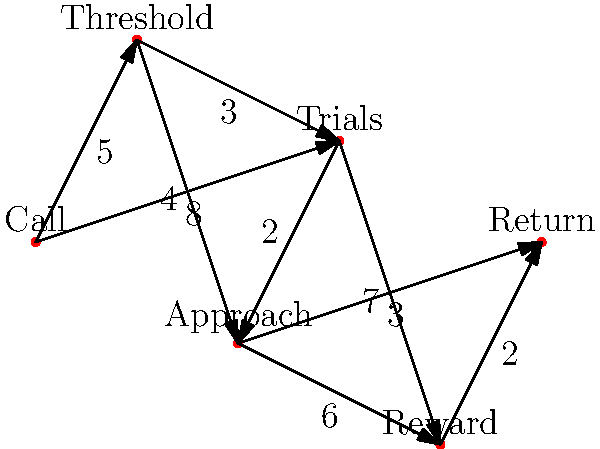In the hero's journey graph above, each node represents a key plot point, and the edges represent the narrative transitions between them, with weights indicating the complexity of the transition. What is the shortest path from "Call" to "Return," and what is its total weight? List the nodes in order and provide the sum of the weights. To find the shortest path, we'll use Dijkstra's algorithm:

1. Start at "Call" with distance 0, all other nodes infinity.
2. Visit unvisited node with smallest distance:
   a. "Call" (0): Update neighbors
      "Threshold" = 5, "Trials" = 8
   b. "Threshold" (5): Update neighbors
      "Trials" = min(8, 5+3) = 8, "Approach" = 5+4 = 9
   c. "Trials" (8): Update neighbors
      "Approach" = min(9, 8+2) = 8+2 = 10, "Reward" = 8+7 = 15
   d. "Approach" (10): Update neighbors
      "Reward" = min(15, 10+6) = 15, "Return" = 10+3 = 13
   e. "Return" (13): Destination reached

3. Backtrack to find the path:
   Return <- Approach <- Trials <- Threshold <- Call

4. Sum the weights: 3 + 2 + 3 + 5 = 13

Therefore, the shortest path is Call -> Threshold -> Trials -> Approach -> Return, with a total weight of 13.
Answer: Call -> Threshold -> Trials -> Approach -> Return; 13 